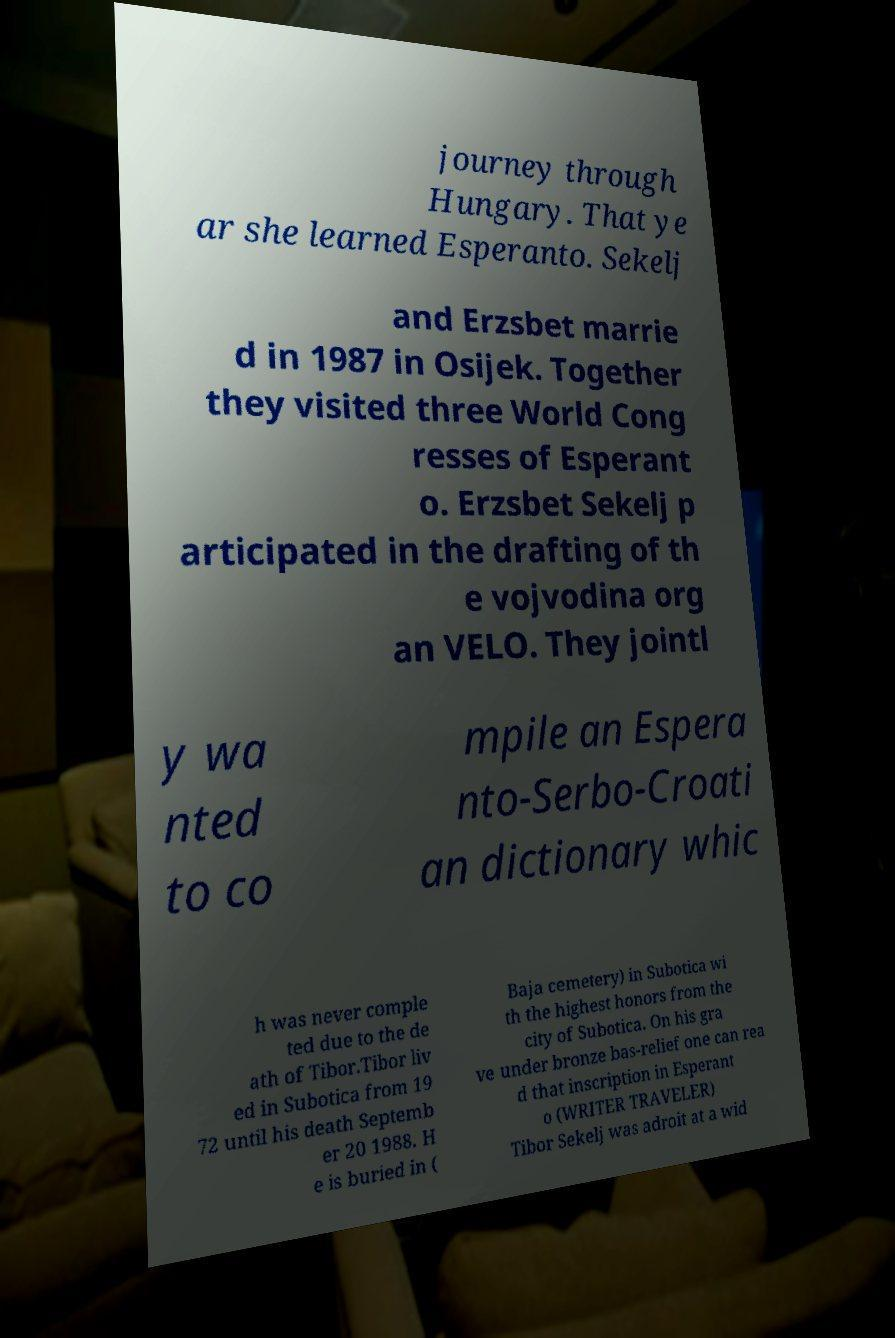Can you accurately transcribe the text from the provided image for me? journey through Hungary. That ye ar she learned Esperanto. Sekelj and Erzsbet marrie d in 1987 in Osijek. Together they visited three World Cong resses of Esperant o. Erzsbet Sekelj p articipated in the drafting of th e vojvodina org an VELO. They jointl y wa nted to co mpile an Espera nto-Serbo-Croati an dictionary whic h was never comple ted due to the de ath of Tibor.Tibor liv ed in Subotica from 19 72 until his death Septemb er 20 1988. H e is buried in ( Baja cemetery) in Subotica wi th the highest honors from the city of Subotica. On his gra ve under bronze bas-relief one can rea d that inscription in Esperant o (WRITER TRAVELER) Tibor Sekelj was adroit at a wid 